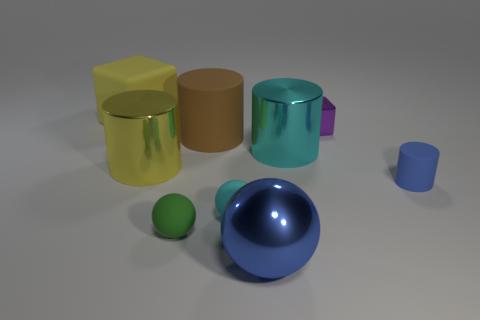Subtract all balls. How many objects are left? 6 Subtract 0 green blocks. How many objects are left? 9 Subtract all large purple cylinders. Subtract all brown objects. How many objects are left? 8 Add 7 cyan rubber things. How many cyan rubber things are left? 8 Add 4 large yellow cylinders. How many large yellow cylinders exist? 5 